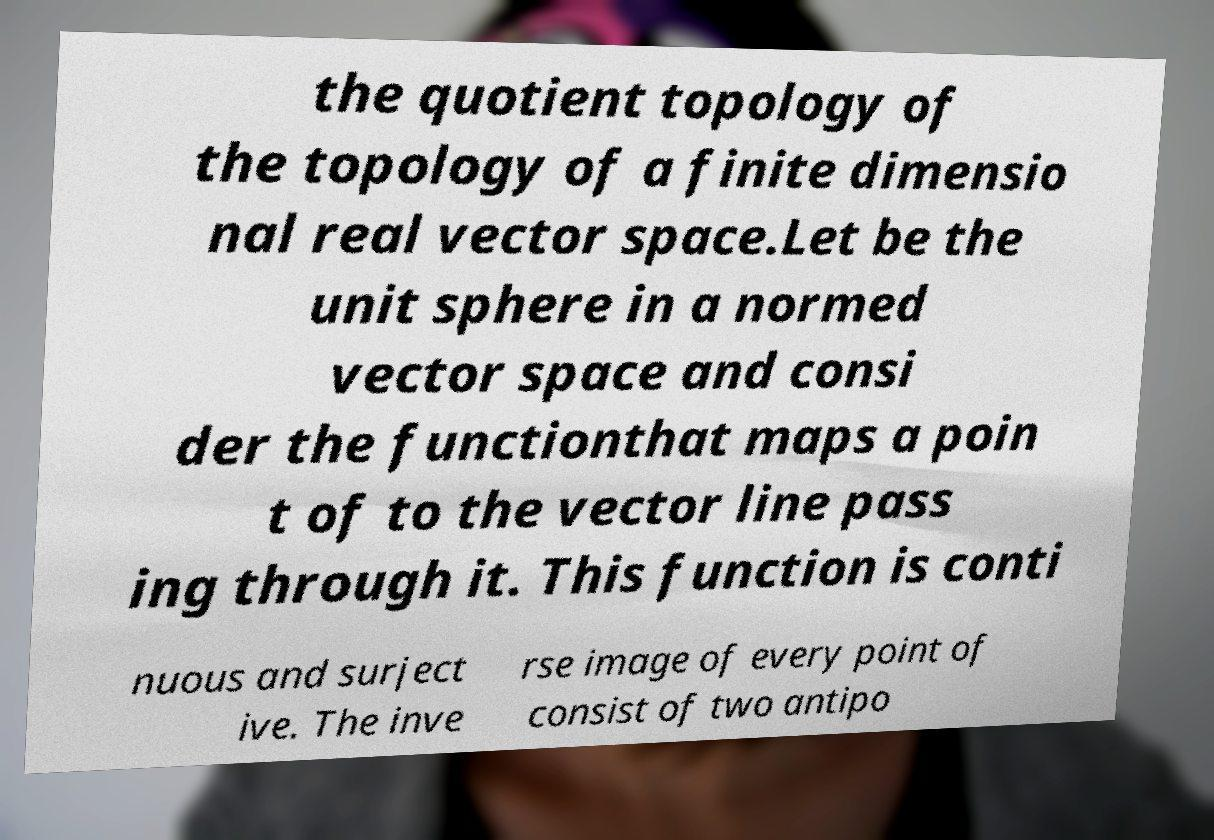There's text embedded in this image that I need extracted. Can you transcribe it verbatim? the quotient topology of the topology of a finite dimensio nal real vector space.Let be the unit sphere in a normed vector space and consi der the functionthat maps a poin t of to the vector line pass ing through it. This function is conti nuous and surject ive. The inve rse image of every point of consist of two antipo 